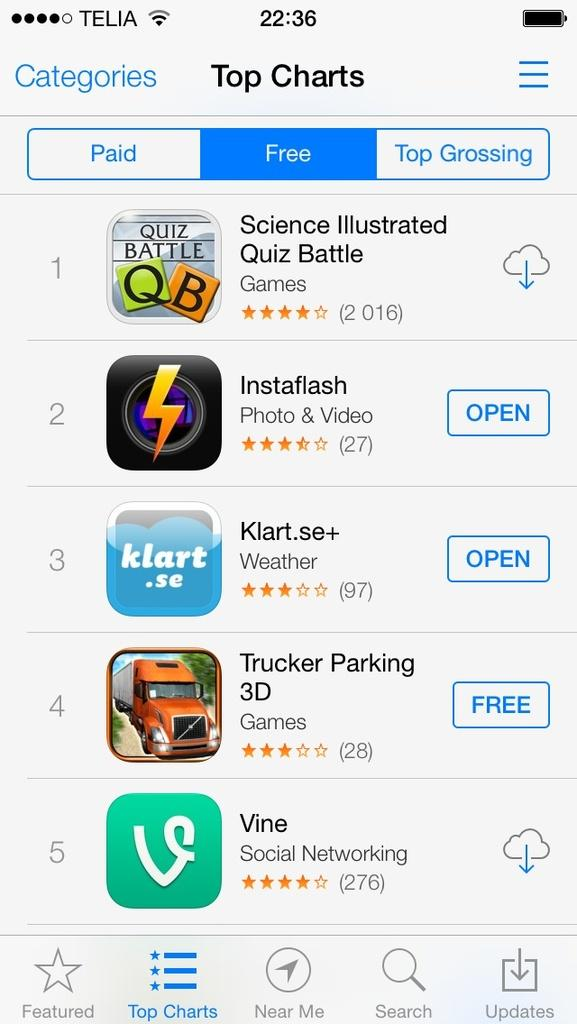What can be found on the web page? There are apps and text on the web page. Can you describe the apps on the web page? The provided facts do not give specific details about the apps, but they are present on the web page. What language is the hammer written in on the web page? There is no mention of a hammer on the web page, so this question cannot be answered. 